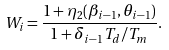Convert formula to latex. <formula><loc_0><loc_0><loc_500><loc_500>W _ { i } = \frac { 1 + \eta _ { 2 } ( \beta _ { i - 1 } , \theta _ { i - 1 } ) } { 1 + \delta _ { i - 1 } T _ { d } / T _ { m } } .</formula> 